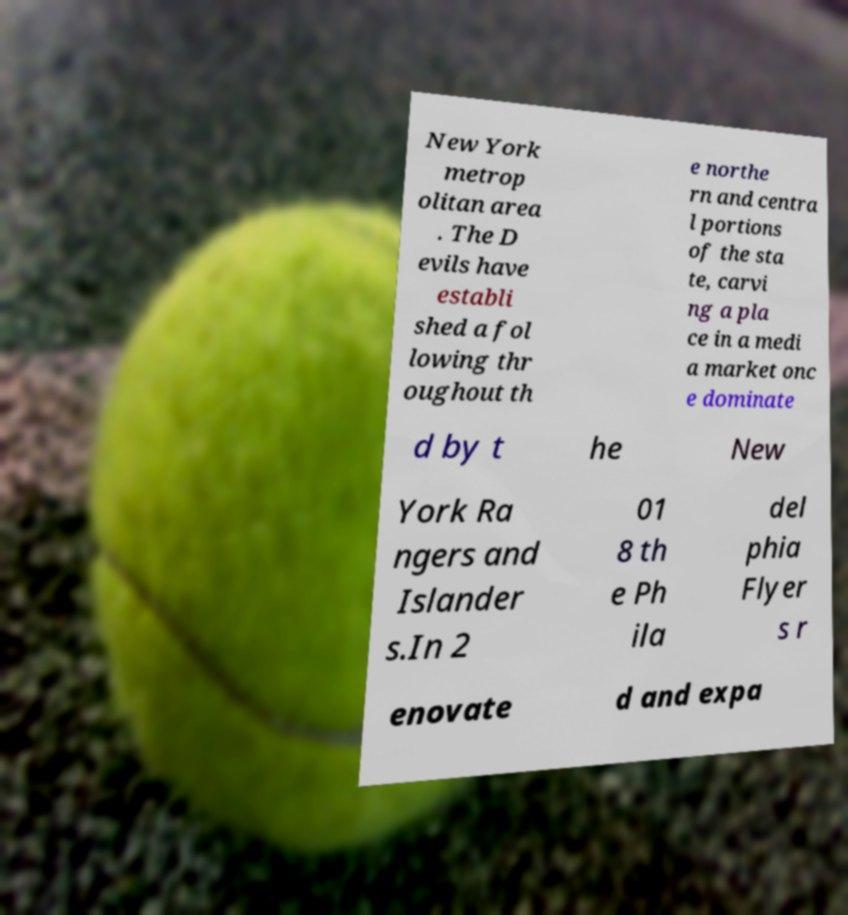Can you read and provide the text displayed in the image?This photo seems to have some interesting text. Can you extract and type it out for me? New York metrop olitan area . The D evils have establi shed a fol lowing thr oughout th e northe rn and centra l portions of the sta te, carvi ng a pla ce in a medi a market onc e dominate d by t he New York Ra ngers and Islander s.In 2 01 8 th e Ph ila del phia Flyer s r enovate d and expa 